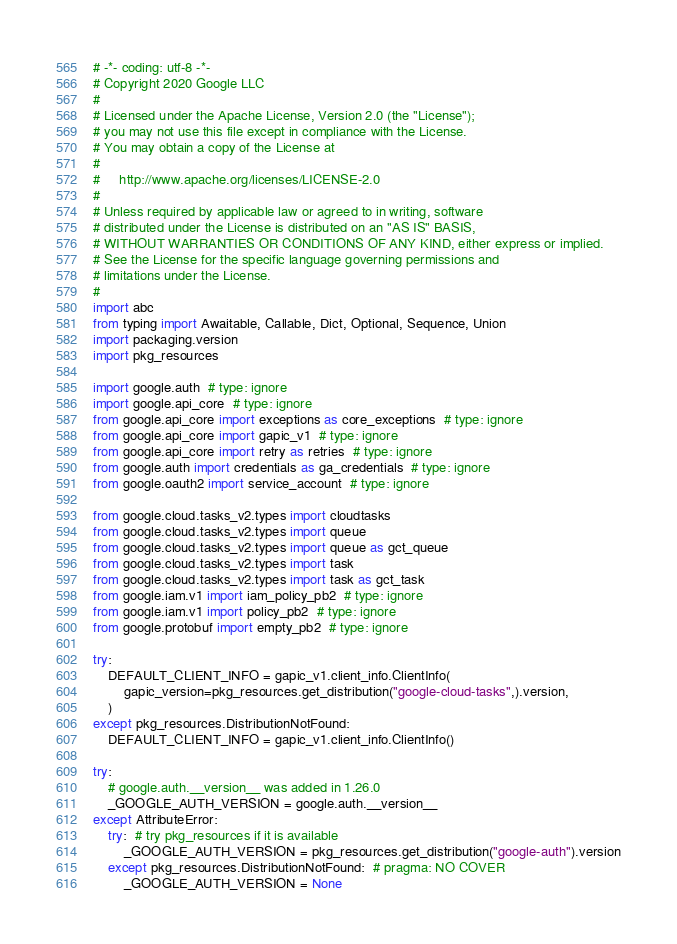Convert code to text. <code><loc_0><loc_0><loc_500><loc_500><_Python_># -*- coding: utf-8 -*-
# Copyright 2020 Google LLC
#
# Licensed under the Apache License, Version 2.0 (the "License");
# you may not use this file except in compliance with the License.
# You may obtain a copy of the License at
#
#     http://www.apache.org/licenses/LICENSE-2.0
#
# Unless required by applicable law or agreed to in writing, software
# distributed under the License is distributed on an "AS IS" BASIS,
# WITHOUT WARRANTIES OR CONDITIONS OF ANY KIND, either express or implied.
# See the License for the specific language governing permissions and
# limitations under the License.
#
import abc
from typing import Awaitable, Callable, Dict, Optional, Sequence, Union
import packaging.version
import pkg_resources

import google.auth  # type: ignore
import google.api_core  # type: ignore
from google.api_core import exceptions as core_exceptions  # type: ignore
from google.api_core import gapic_v1  # type: ignore
from google.api_core import retry as retries  # type: ignore
from google.auth import credentials as ga_credentials  # type: ignore
from google.oauth2 import service_account  # type: ignore

from google.cloud.tasks_v2.types import cloudtasks
from google.cloud.tasks_v2.types import queue
from google.cloud.tasks_v2.types import queue as gct_queue
from google.cloud.tasks_v2.types import task
from google.cloud.tasks_v2.types import task as gct_task
from google.iam.v1 import iam_policy_pb2  # type: ignore
from google.iam.v1 import policy_pb2  # type: ignore
from google.protobuf import empty_pb2  # type: ignore

try:
    DEFAULT_CLIENT_INFO = gapic_v1.client_info.ClientInfo(
        gapic_version=pkg_resources.get_distribution("google-cloud-tasks",).version,
    )
except pkg_resources.DistributionNotFound:
    DEFAULT_CLIENT_INFO = gapic_v1.client_info.ClientInfo()

try:
    # google.auth.__version__ was added in 1.26.0
    _GOOGLE_AUTH_VERSION = google.auth.__version__
except AttributeError:
    try:  # try pkg_resources if it is available
        _GOOGLE_AUTH_VERSION = pkg_resources.get_distribution("google-auth").version
    except pkg_resources.DistributionNotFound:  # pragma: NO COVER
        _GOOGLE_AUTH_VERSION = None

</code> 